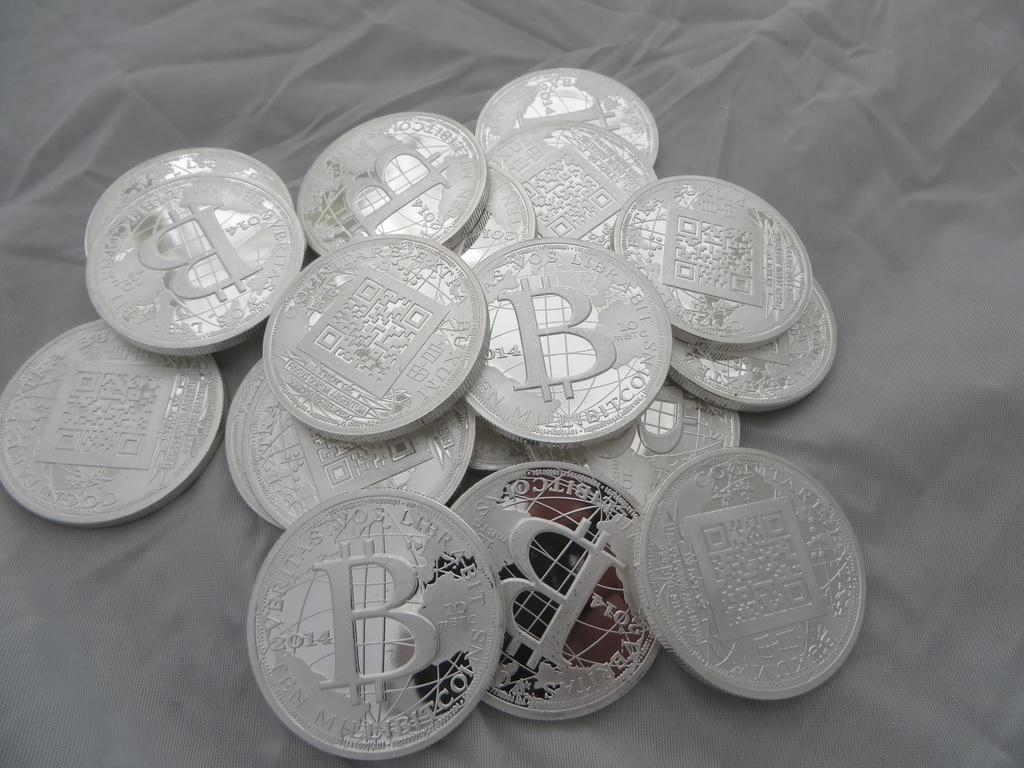<image>
Render a clear and concise summary of the photo. A bunch of silver coins with a B on them piled up. 